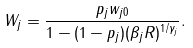Convert formula to latex. <formula><loc_0><loc_0><loc_500><loc_500>W _ { j } = \frac { p _ { j } w _ { j 0 } } { 1 - ( 1 - p _ { j } ) ( \beta _ { j } R ) ^ { 1 / \gamma _ { j } } } .</formula> 